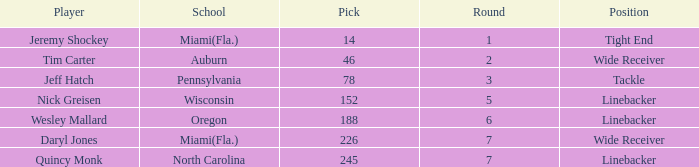From what school was the player drafted in round 3? Pennsylvania. 